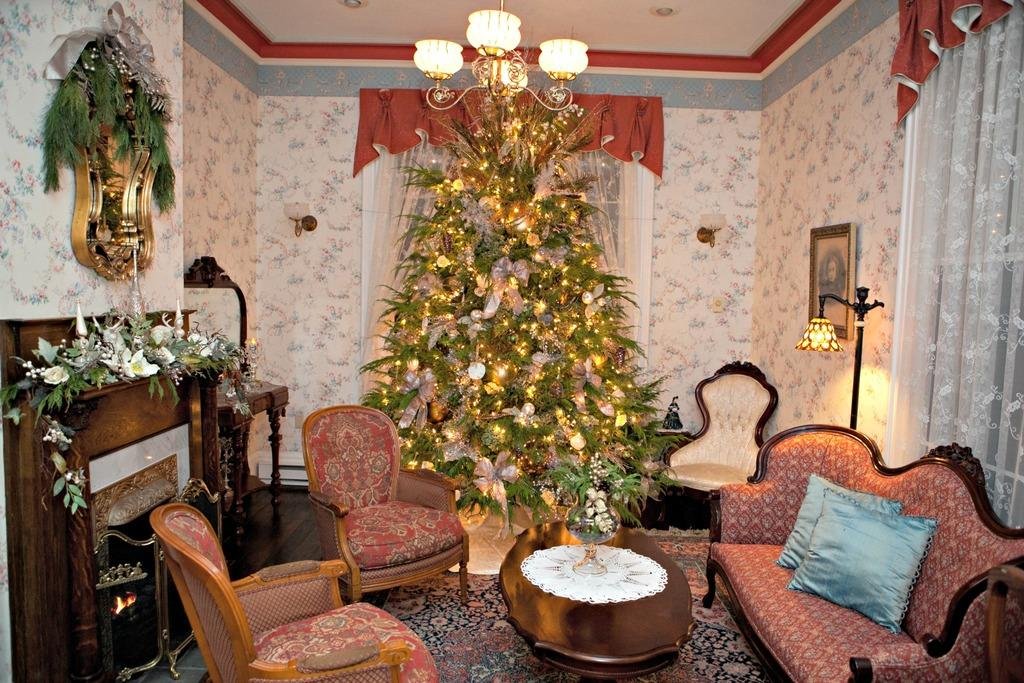What type of furniture is in the image? There is a red sofa set in the image. What is located behind the sofa set? There is a tree behind the sofa set. What color are the walls in the image? The walls are white in color. What type of pancake is being served at the birthday party in the image? There is no pancake or birthday party present in the image. 